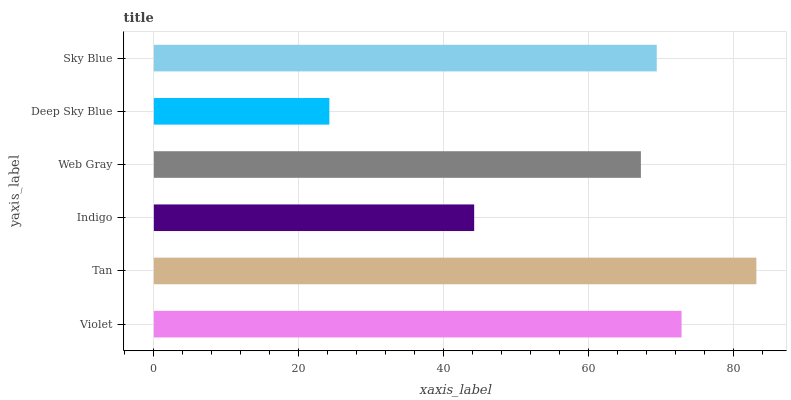Is Deep Sky Blue the minimum?
Answer yes or no. Yes. Is Tan the maximum?
Answer yes or no. Yes. Is Indigo the minimum?
Answer yes or no. No. Is Indigo the maximum?
Answer yes or no. No. Is Tan greater than Indigo?
Answer yes or no. Yes. Is Indigo less than Tan?
Answer yes or no. Yes. Is Indigo greater than Tan?
Answer yes or no. No. Is Tan less than Indigo?
Answer yes or no. No. Is Sky Blue the high median?
Answer yes or no. Yes. Is Web Gray the low median?
Answer yes or no. Yes. Is Tan the high median?
Answer yes or no. No. Is Violet the low median?
Answer yes or no. No. 